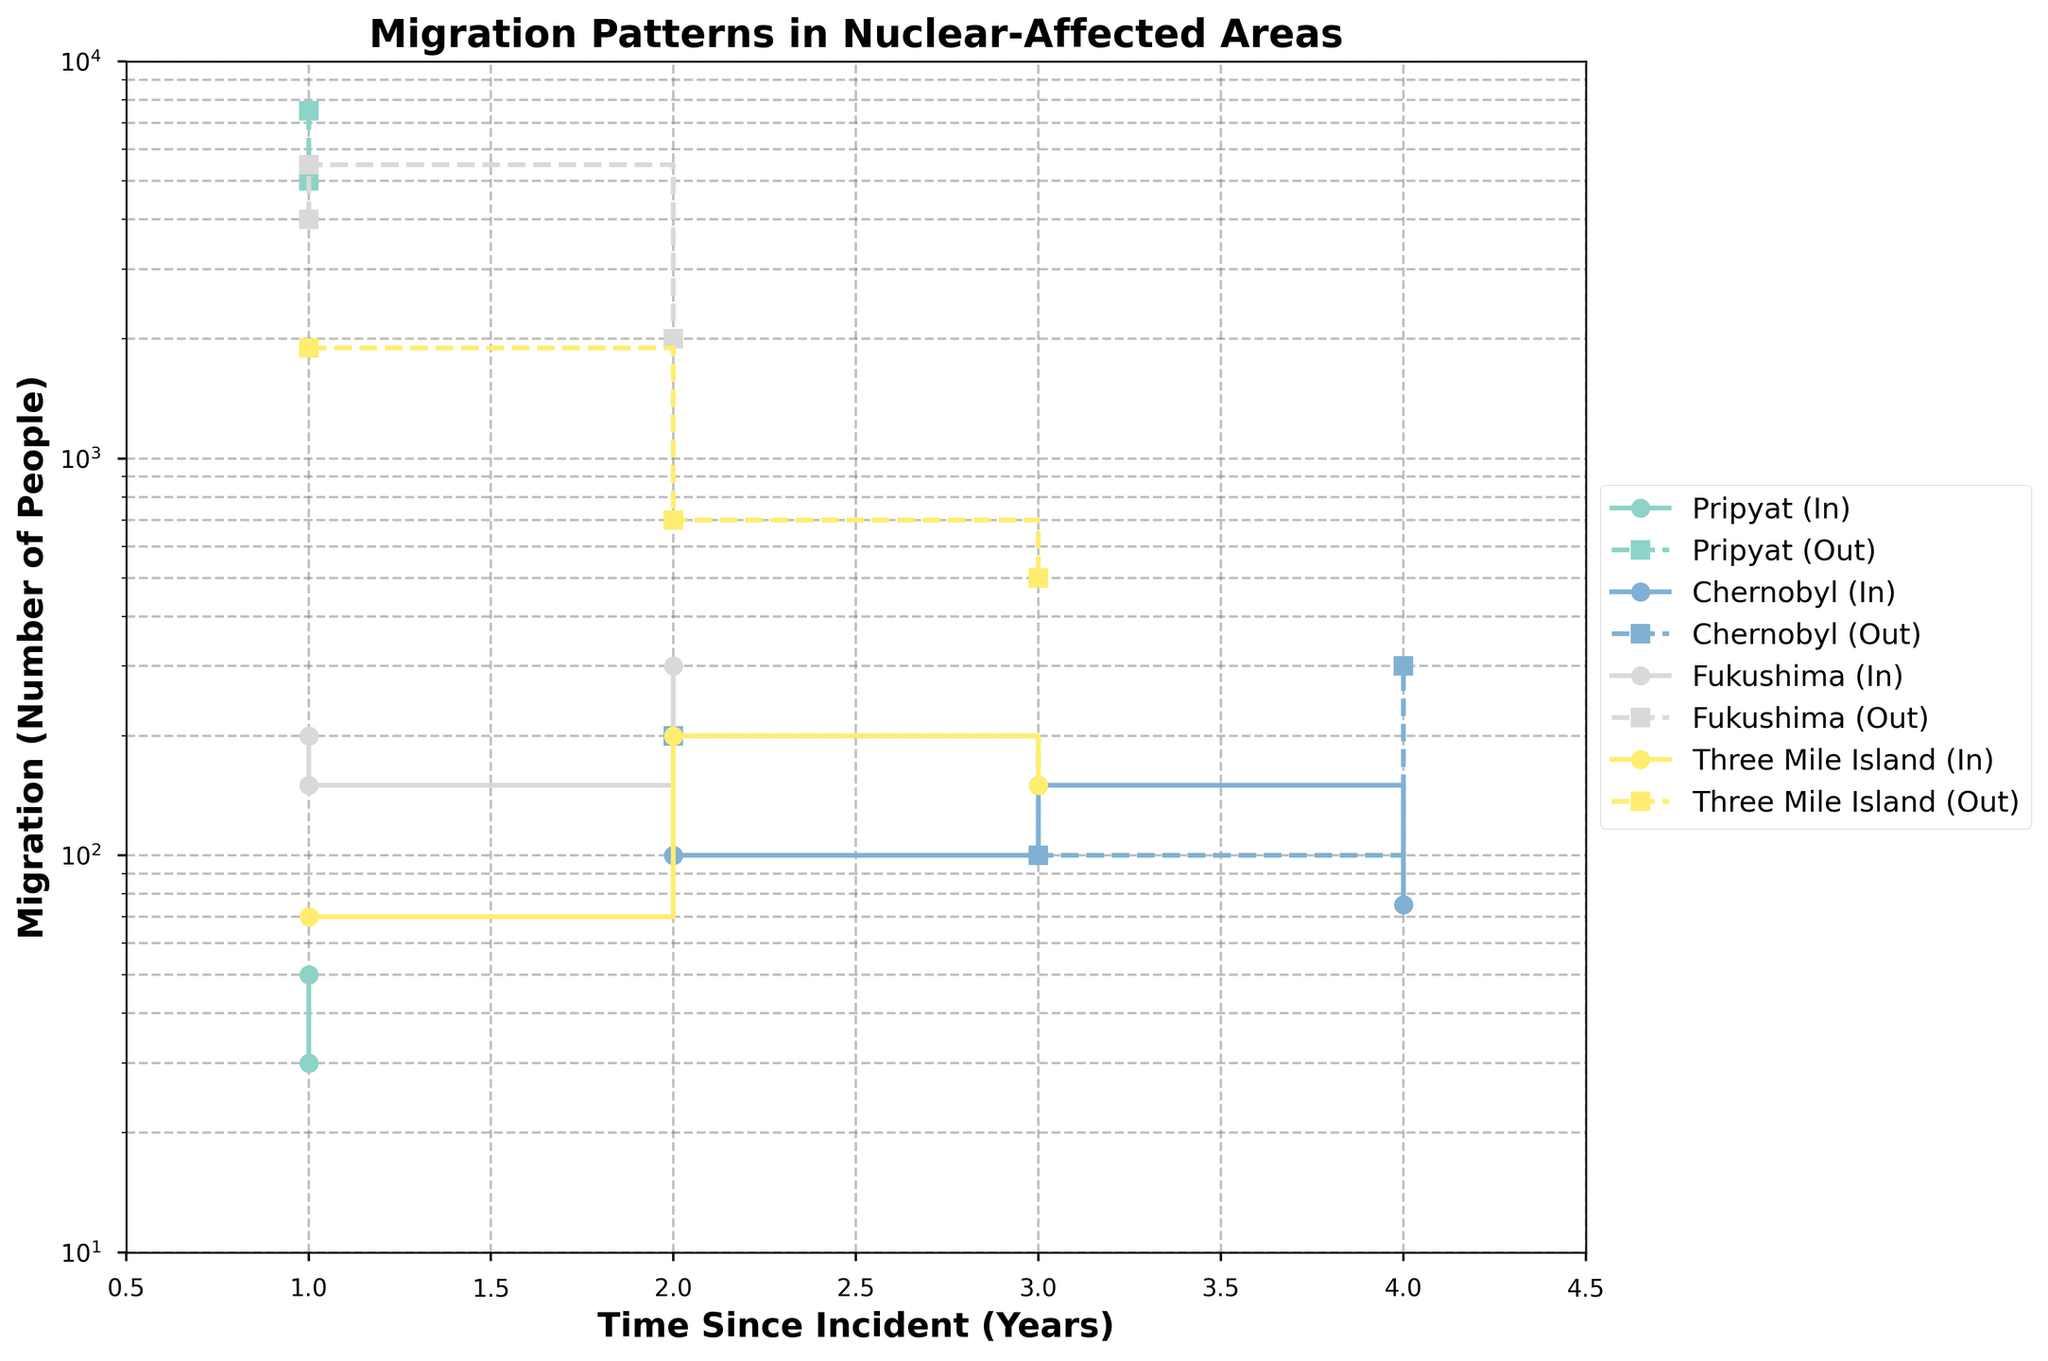What is the title of the figure? The title of the figure is usually displayed at the top, and it provides an overview of the data being presented. In this case, the title helps to understand that the plot is about migration patterns in nuclear-affected areas.
Answer: Migration Patterns in Nuclear-Affected Areas Which community shows the highest in-migration in the first year post-incident? To find this, we look at the in-migration values for each community at "Time Since Incident" = 1. Comparing these values, Pripyat has an in-migration of 50 for job opportunities and 30 for health concerns, while Fukushima has an in-migration of 200 for job opportunities and 150 for health concerns. The highest in-migration in the first year is from Fukushima.
Answer: Fukushima Which community had more out-migration due to health concerns in the first year post-incident: Pripyat or Fukushima? We compare out-migration values due to health concerns in the first year for both Pripyat and Fukushima. Pripyat had 7500 out-migrations due to health concerns, while Fukushima had 5500 out-migrations. Pripyat had more out-migration due to health concerns.
Answer: Pripyat How does the in-migration trend for Chernobyl change over time since the incident? For Chernobyl, we need to observe the in-migration values at different "Time Since Incident" points. The values are: 100 (Year 2), 150 (Year 3), and 75 (Year 4). The trend initially increases from Year 2 to Year 3 and then decreases by Year 4.
Answer: Increases then decreases Compared to other communities, which one shows the least variation in out-migration from 1 to 4 years post-incident? To determine this, check the range of out-migration values for each community over the years. Pripyat's out-migration values are 5000 and 7500; Chernobyl's are 200, 100, and 300; Fukushima's are 4000, 5500, and 2000; Three Mile Island's are 1900, 700, and 500. Chernobyl has the least variation.
Answer: Chernobyl How many different reasons for moving are listed for Three Mile Island? By examining the reasons for moving associated with Three Mile Island, we see: "Perceived Safety," "Affordable Housing," and "Business Investments," which makes a total of three different reasons.
Answer: 3 What is the average out-migration value for Fukushima across all the years shown? First, sum the out-migration values for Fukushima: 4000 (Year 1), 5500 (Year 1), and 2000 (Year 2). The sum is 11500. There are three data points, so the average out-migration is 11500 / 3 = 3833.33
Answer: 3833.33 Which reason for moving shows the highest in-migration value, and what is that value? Checking in-migration values across the data, the highest values are: 50, 30, 100, 150, 75, 200, 150, 300, 70, 200, 150. The highest is 300 for "Govt. Relocation Incentives" in Fukushima.
Answer: Govt. Relocation Incentives, 300 